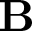Convert formula to latex. <formula><loc_0><loc_0><loc_500><loc_500>B</formula> 